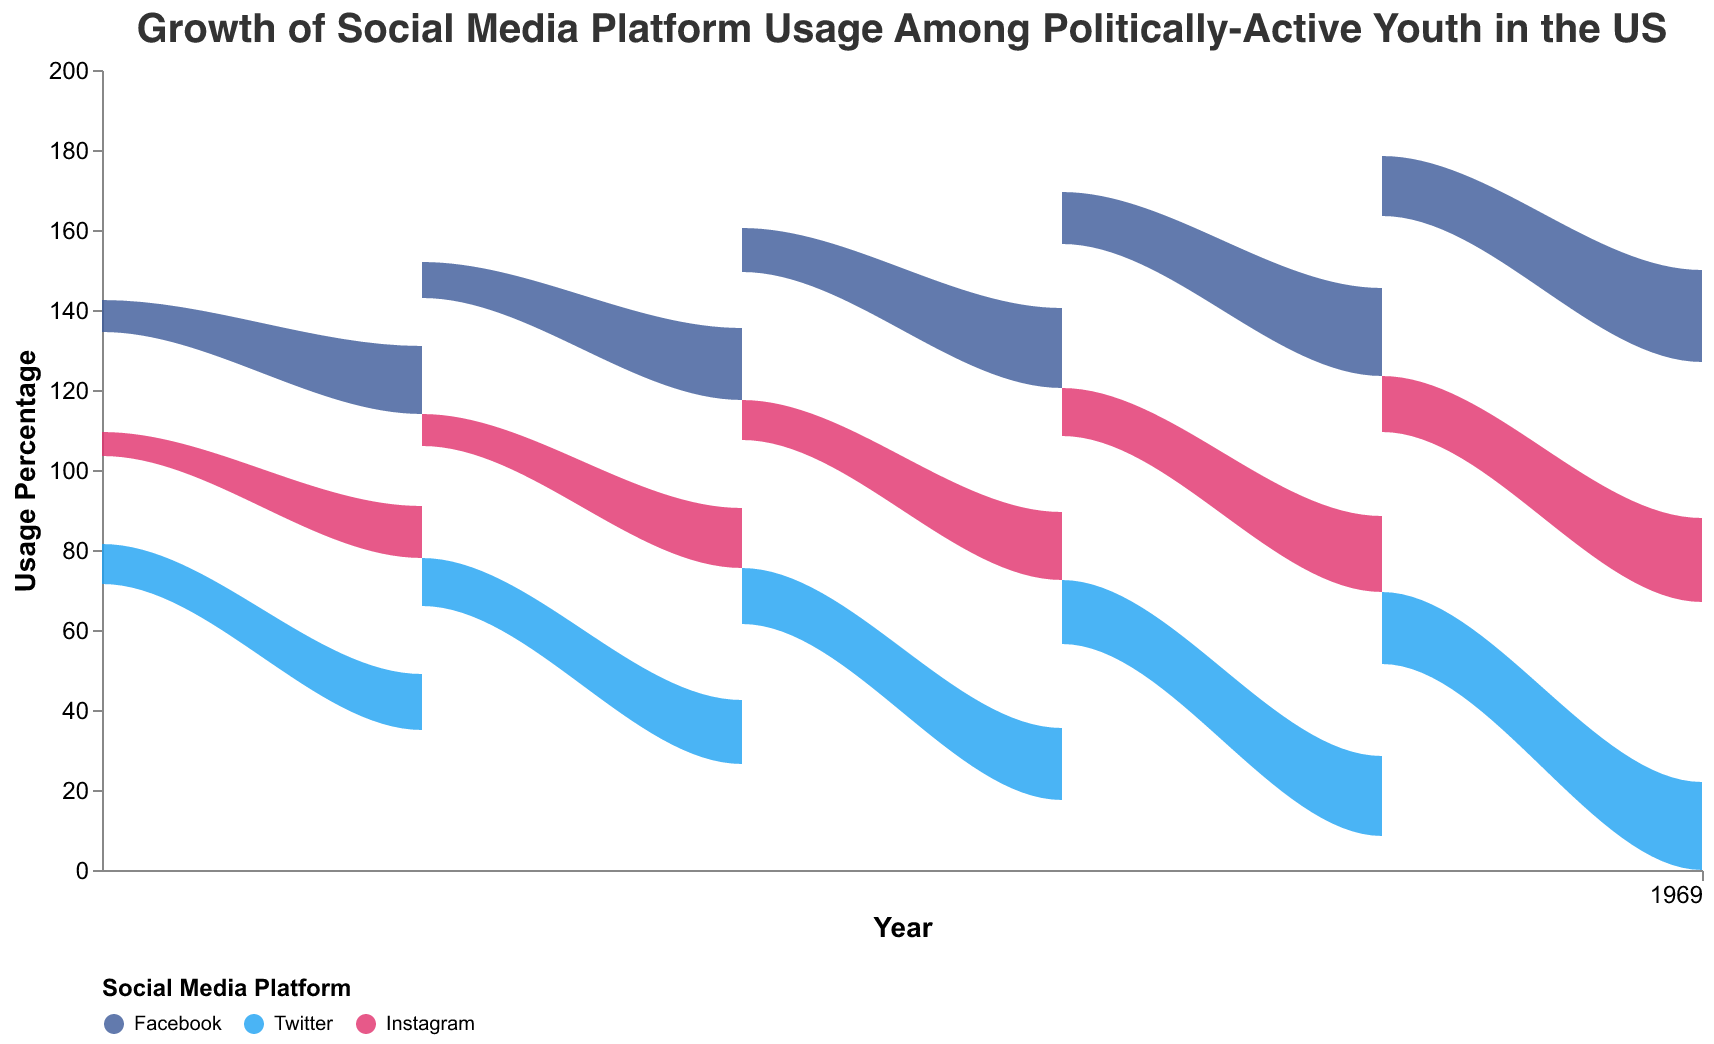What is the title of the figure? The title is located at the top of the figure and reads "Growth of Social Media Platform Usage Among Politically-Active Youth in the US".
Answer: Growth of Social Media Platform Usage Among Politically-Active Youth in the US Which platform had the highest usage percentage for social justice activism weekly in 2022? By visually examining the figure’s color coding and the stacked areas corresponding to social media platforms in 2022, the color representing Twitter has the highest stacked area for weekly social justice engagement.
Answer: Twitter Between Facebook and Instagram, which platform showed a higher percentage increase from 2017 to 2022 for daily environmental activism? Look at the height difference of the areas for Facebook and Instagram from 2017 to 2022 for daily environmental activism. Facebook increased from 15% to 23% (8% increase), while Instagram increased from 10% to 21% (11% increase). Instagram has a higher percentage increase.
Answer: Instagram For the year 2020, what was the total usage percentage for all platforms combined for monthly political campaigns engagement? Add the usage percentages for Facebook (13%), Twitter (16%), and Instagram (12%) for monthly political campaigns in 2020. 13% + 16% + 12% = 41%.
Answer: 41% How did the usage percentage of Twitter for weekly social justice activism change from 2019 to 2022? Check the stacked area height for Twitter's weekly social justice engagement in 2019 (19%) and compare it to 2022 (25%). The change is 25% - 19% = 6%.
Answer: 6% Which type of activism had the highest engagement frequency usage overall in 2021? Identify the type of activism with the widest stacked area at the highest point in the vertical axis in 2021 for all platforms combined. Daily environmental activism has the highest overall engagement at 22% (Facebook) + 20% (Twitter) + 19% (Instagram) = 61%.
Answer: Environmental activism Compare the trends of Instagram and Facebook for monthly political campaigns from 2017 to 2022. Which trend shows a consistent increase? Evaluate the stacked areas’ heights of Instagram and Facebook for monthly political campaigns from 2017 to 2022. Facebook increases continuously from 8% to 17%, while Instagram fluctuates. Thus, Facebook shows a consistent increase.
Answer: Facebook In 2018, which platform had the lowest usage percentage for environmental activism on a daily basis? Compare the stacked areas for daily environmental activism in 2018 across all platforms; Instagram has the lowest height, corresponding to 13%.
Answer: Instagram 